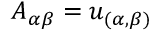Convert formula to latex. <formula><loc_0><loc_0><loc_500><loc_500>A _ { \alpha \beta } = u _ { ( \alpha , \beta ) }</formula> 